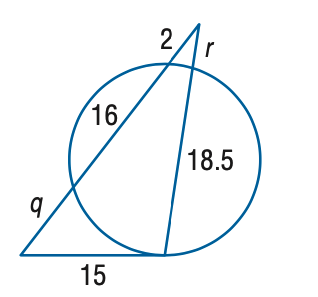Answer the mathemtical geometry problem and directly provide the correct option letter.
Question: Find the variable of q to the nearest tenth. Assume that segments that appear to be tangent are tangent.
Choices: A: 6.0 B: 7.0 C: 8.0 D: 9.0 D 